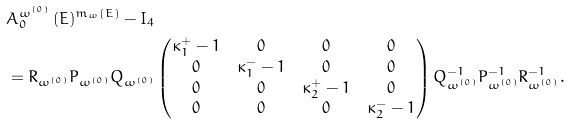Convert formula to latex. <formula><loc_0><loc_0><loc_500><loc_500>& A _ { 0 } ^ { \omega ^ { ( 0 ) } } \, ( E ) ^ { m _ { \omega } ( E ) } - I _ { 4 } \\ & = R _ { \omega ^ { ( 0 ) } } P _ { \omega ^ { ( 0 ) } } Q _ { \omega ^ { ( 0 ) } } \begin{pmatrix} \kappa _ { 1 } ^ { + } - 1 & 0 & 0 & 0 \\ 0 & \kappa _ { 1 } ^ { - } - 1 & 0 & 0 \\ 0 & 0 & \kappa _ { 2 } ^ { + } - 1 & 0 \\ 0 & 0 & 0 & \kappa _ { 2 } ^ { - } - 1 \end{pmatrix} Q _ { \omega ^ { ( 0 ) } } ^ { - 1 } P _ { \omega ^ { ( 0 ) } } ^ { - 1 } R _ { \omega ^ { ( 0 ) } } ^ { - 1 } .</formula> 